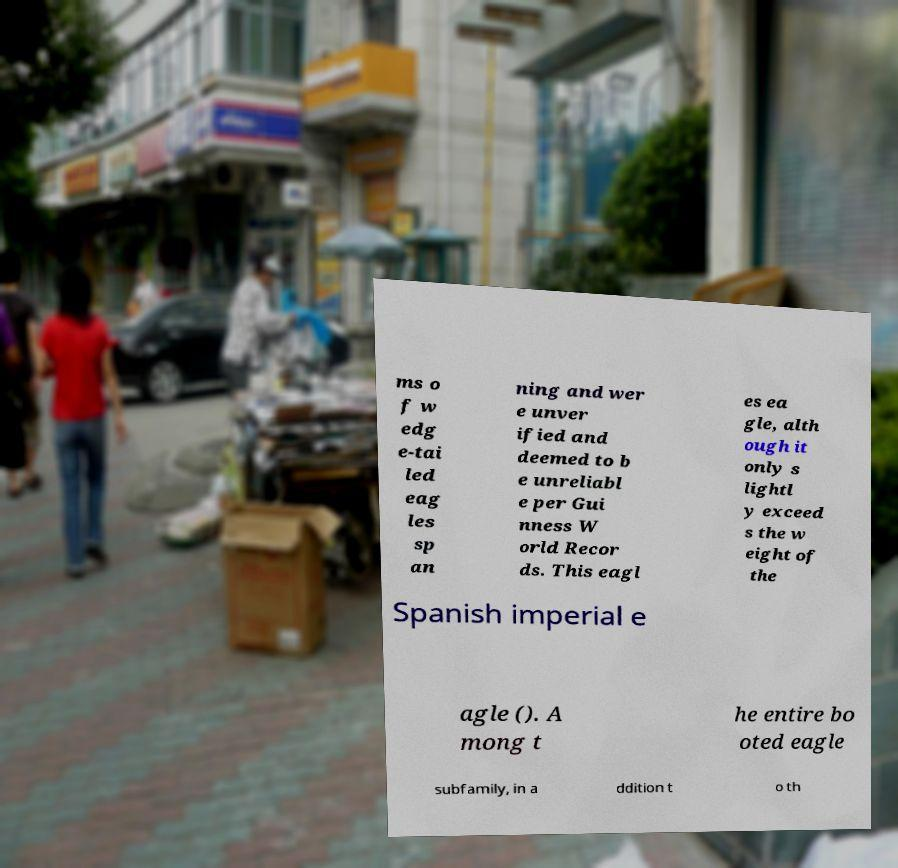Please identify and transcribe the text found in this image. ms o f w edg e-tai led eag les sp an ning and wer e unver ified and deemed to b e unreliabl e per Gui nness W orld Recor ds. This eagl es ea gle, alth ough it only s lightl y exceed s the w eight of the Spanish imperial e agle (). A mong t he entire bo oted eagle subfamily, in a ddition t o th 